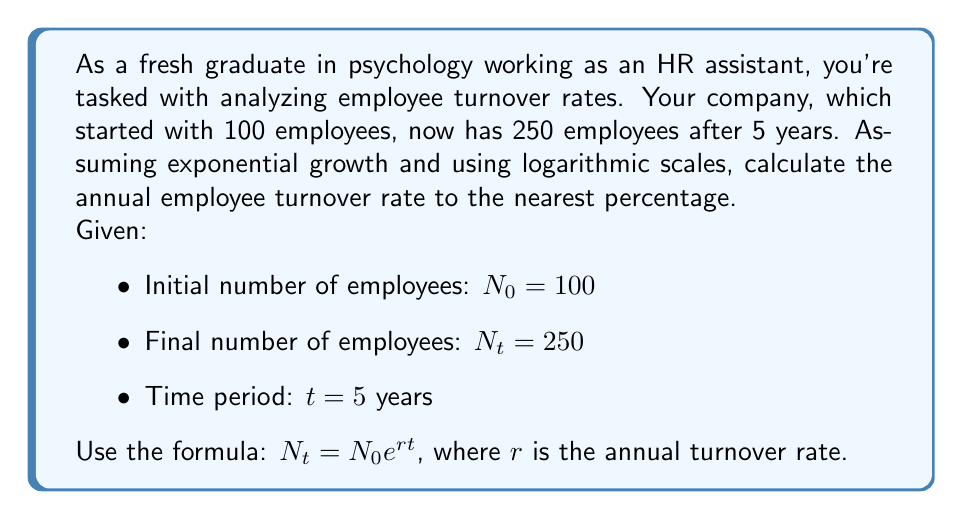Could you help me with this problem? To solve this problem, we'll use the exponential growth formula and logarithms:

1) Start with the exponential growth formula:
   $N_t = N_0 e^{rt}$

2) Substitute the known values:
   $250 = 100 e^{5r}$

3) Divide both sides by 100:
   $2.5 = e^{5r}$

4) Take the natural logarithm of both sides:
   $\ln(2.5) = \ln(e^{5r})$

5) Simplify the right side using the logarithm property $\ln(e^x) = x$:
   $\ln(2.5) = 5r$

6) Solve for $r$:
   $r = \frac{\ln(2.5)}{5}$

7) Calculate the value:
   $r = \frac{0.9162907318741551}{5} = 0.1832581463748310$

8) Convert to a percentage and round to the nearest whole number:
   $r \approx 18\%$

This represents the annual growth rate. To interpret this as turnover, we can say that the company is growing by 18% annually, which implies that they are hiring more people than they are losing, resulting in a net positive turnover rate.
Answer: The annual employee turnover rate is approximately 18%. 